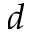Convert formula to latex. <formula><loc_0><loc_0><loc_500><loc_500>d</formula> 